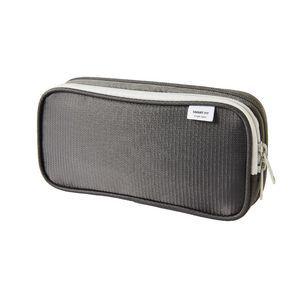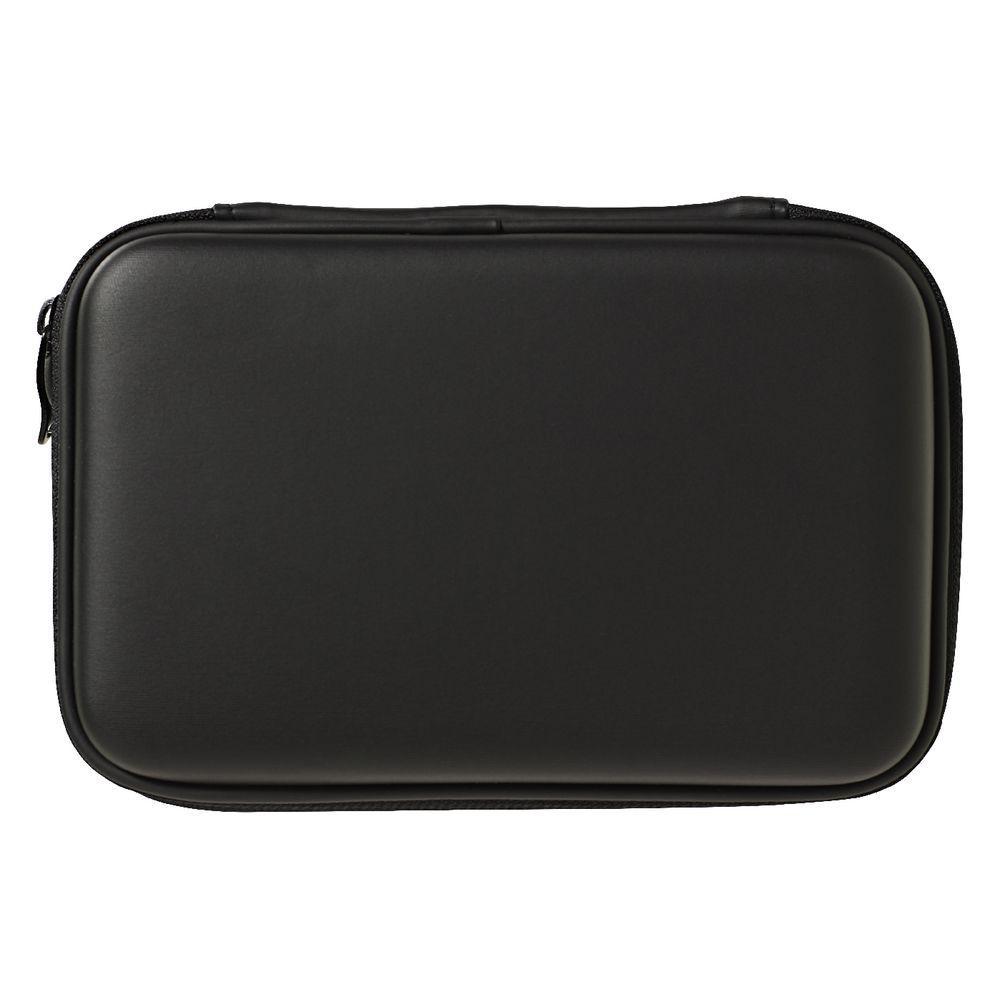The first image is the image on the left, the second image is the image on the right. Given the left and right images, does the statement "Two pencil cases with top zippers are different sizes and only one has a visible tag affixed." hold true? Answer yes or no. Yes. The first image is the image on the left, the second image is the image on the right. For the images displayed, is the sentence "One case is solid color and rectangular with rounded edges, and has two zipper pulls on top to zip the case open, and the other case features a bright warm color." factually correct? Answer yes or no. No. 